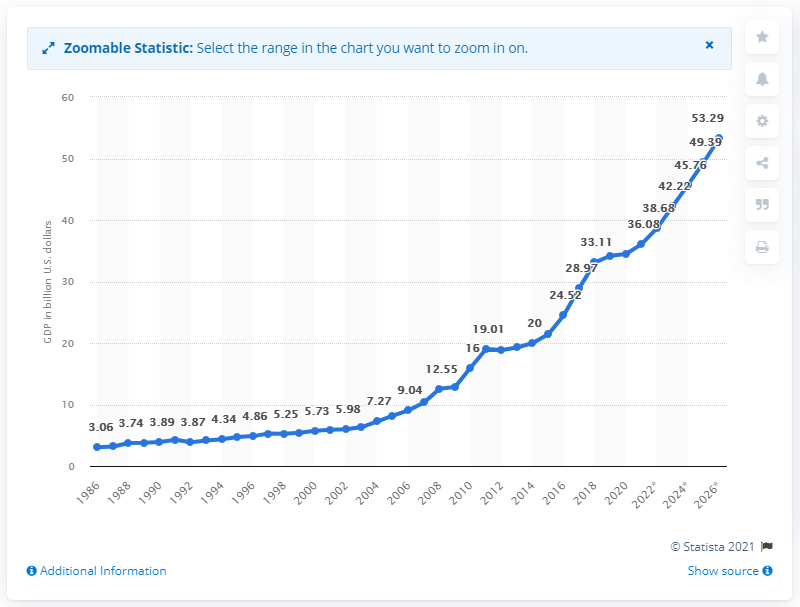Point out several critical features in this image. In 2020, Nepal's GDP was 34.47 billion dollars. 